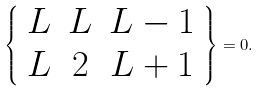<formula> <loc_0><loc_0><loc_500><loc_500>\left \{ \begin{array} { c c c } L & L & L - 1 \\ L & 2 & L + 1 \end{array} \right \} = 0 .</formula> 